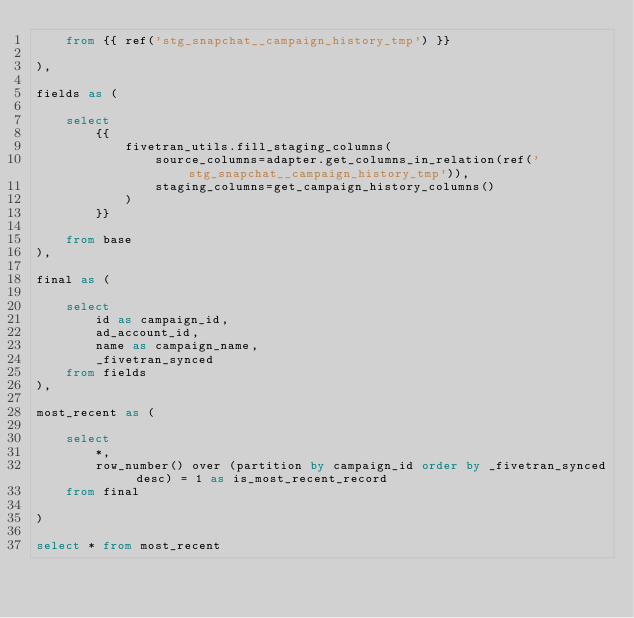Convert code to text. <code><loc_0><loc_0><loc_500><loc_500><_SQL_>    from {{ ref('stg_snapchat__campaign_history_tmp') }}

),

fields as (

    select
        {{
            fivetran_utils.fill_staging_columns(
                source_columns=adapter.get_columns_in_relation(ref('stg_snapchat__campaign_history_tmp')),
                staging_columns=get_campaign_history_columns()
            )
        }}
        
    from base
),

final as (
    
    select 
        id as campaign_id,
        ad_account_id,
        name as campaign_name,
        _fivetran_synced
    from fields
),

most_recent as (

    select 
        *,
        row_number() over (partition by campaign_id order by _fivetran_synced desc) = 1 as is_most_recent_record
    from final

)

select * from most_recent
</code> 